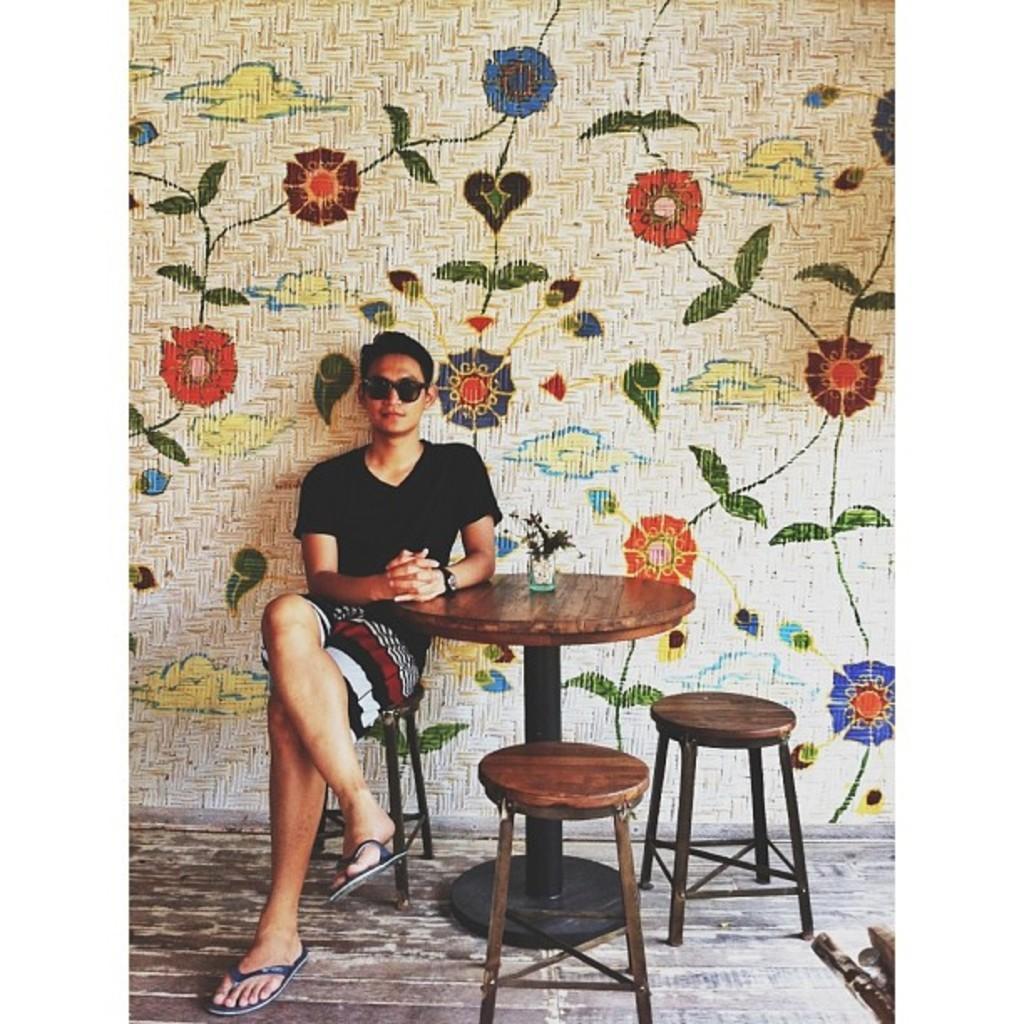How would you summarize this image in a sentence or two? In this picture we can see a man, he is seated on the chair and he wore spectacles, beside to him we can find a table and few chairs. 